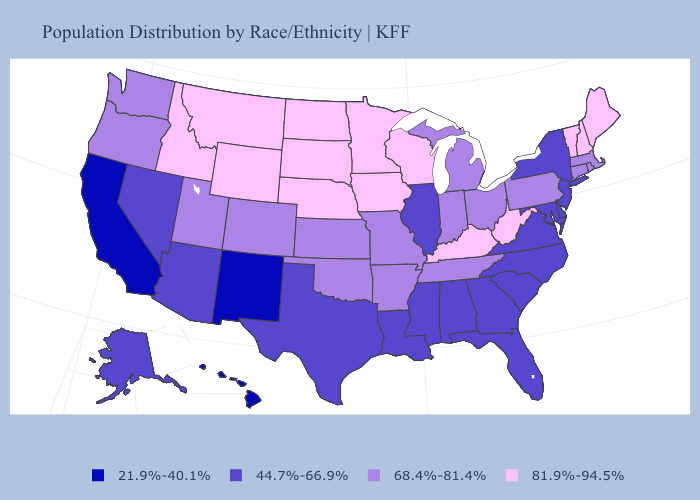What is the value of West Virginia?
Keep it brief. 81.9%-94.5%. Does Georgia have the same value as Tennessee?
Be succinct. No. Name the states that have a value in the range 44.7%-66.9%?
Concise answer only. Alabama, Alaska, Arizona, Delaware, Florida, Georgia, Illinois, Louisiana, Maryland, Mississippi, Nevada, New Jersey, New York, North Carolina, South Carolina, Texas, Virginia. What is the value of New Mexico?
Answer briefly. 21.9%-40.1%. Which states have the highest value in the USA?
Write a very short answer. Idaho, Iowa, Kentucky, Maine, Minnesota, Montana, Nebraska, New Hampshire, North Dakota, South Dakota, Vermont, West Virginia, Wisconsin, Wyoming. Name the states that have a value in the range 81.9%-94.5%?
Be succinct. Idaho, Iowa, Kentucky, Maine, Minnesota, Montana, Nebraska, New Hampshire, North Dakota, South Dakota, Vermont, West Virginia, Wisconsin, Wyoming. Which states hav the highest value in the South?
Short answer required. Kentucky, West Virginia. What is the lowest value in the USA?
Answer briefly. 21.9%-40.1%. What is the value of Delaware?
Quick response, please. 44.7%-66.9%. Name the states that have a value in the range 81.9%-94.5%?
Keep it brief. Idaho, Iowa, Kentucky, Maine, Minnesota, Montana, Nebraska, New Hampshire, North Dakota, South Dakota, Vermont, West Virginia, Wisconsin, Wyoming. Does the first symbol in the legend represent the smallest category?
Answer briefly. Yes. Name the states that have a value in the range 81.9%-94.5%?
Answer briefly. Idaho, Iowa, Kentucky, Maine, Minnesota, Montana, Nebraska, New Hampshire, North Dakota, South Dakota, Vermont, West Virginia, Wisconsin, Wyoming. Does Alabama have a higher value than Arkansas?
Concise answer only. No. Name the states that have a value in the range 68.4%-81.4%?
Keep it brief. Arkansas, Colorado, Connecticut, Indiana, Kansas, Massachusetts, Michigan, Missouri, Ohio, Oklahoma, Oregon, Pennsylvania, Rhode Island, Tennessee, Utah, Washington. Does Montana have the highest value in the USA?
Quick response, please. Yes. 